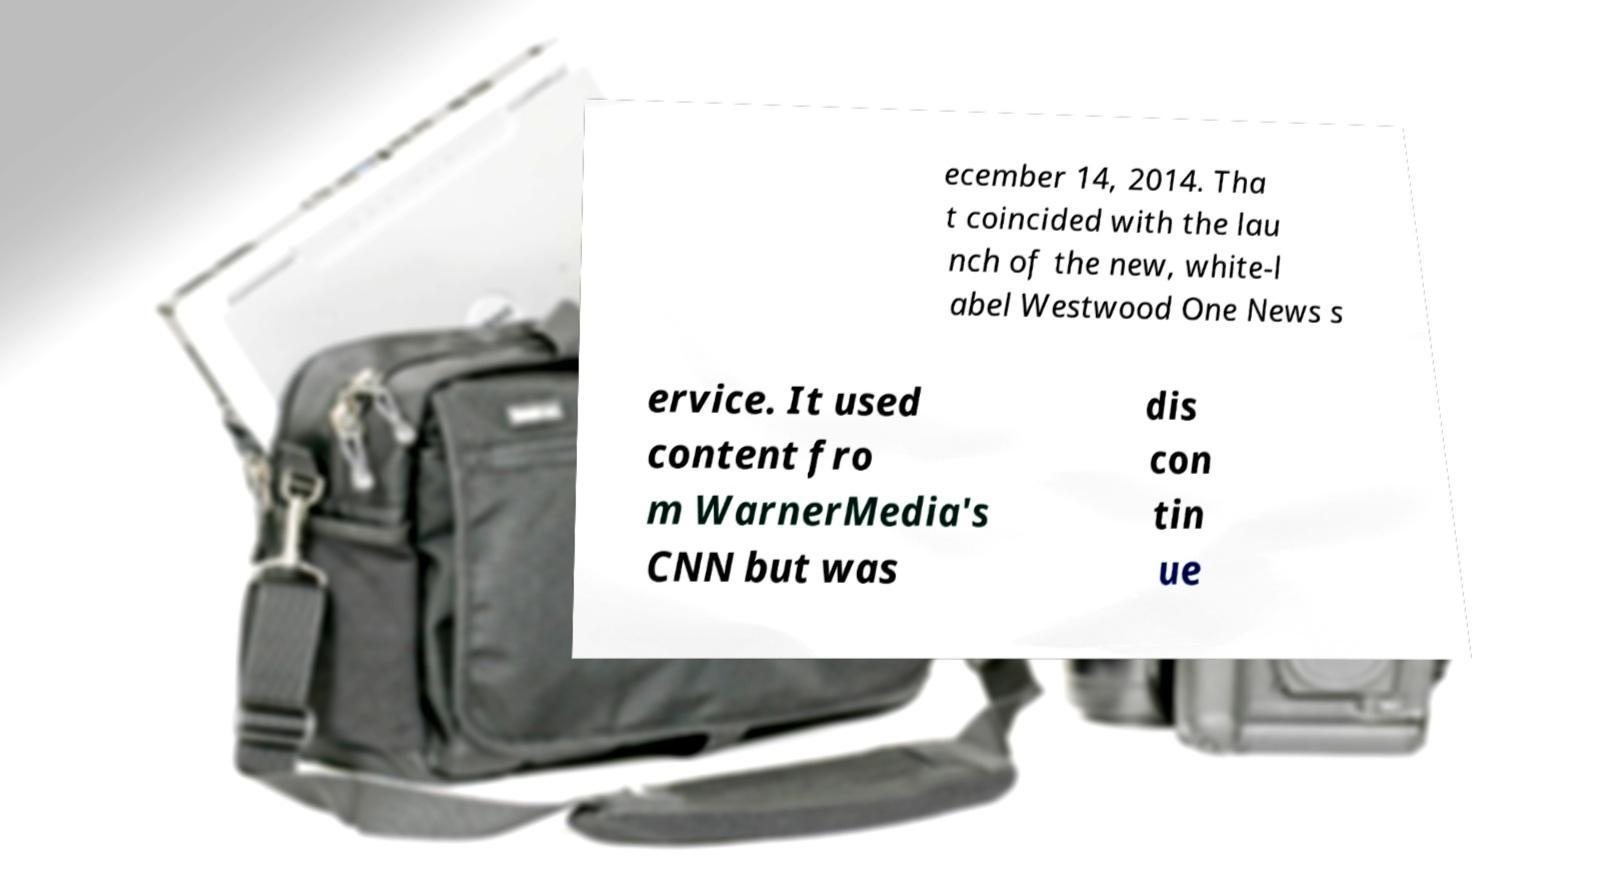Can you accurately transcribe the text from the provided image for me? ecember 14, 2014. Tha t coincided with the lau nch of the new, white-l abel Westwood One News s ervice. It used content fro m WarnerMedia's CNN but was dis con tin ue 